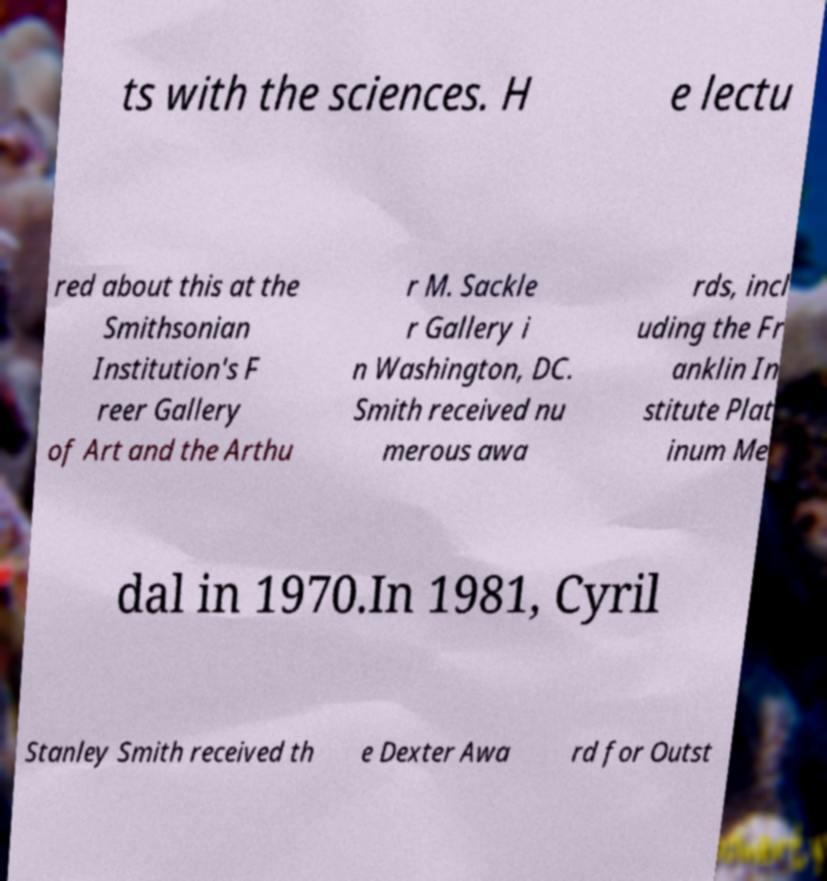Could you assist in decoding the text presented in this image and type it out clearly? ts with the sciences. H e lectu red about this at the Smithsonian Institution's F reer Gallery of Art and the Arthu r M. Sackle r Gallery i n Washington, DC. Smith received nu merous awa rds, incl uding the Fr anklin In stitute Plat inum Me dal in 1970.In 1981, Cyril Stanley Smith received th e Dexter Awa rd for Outst 